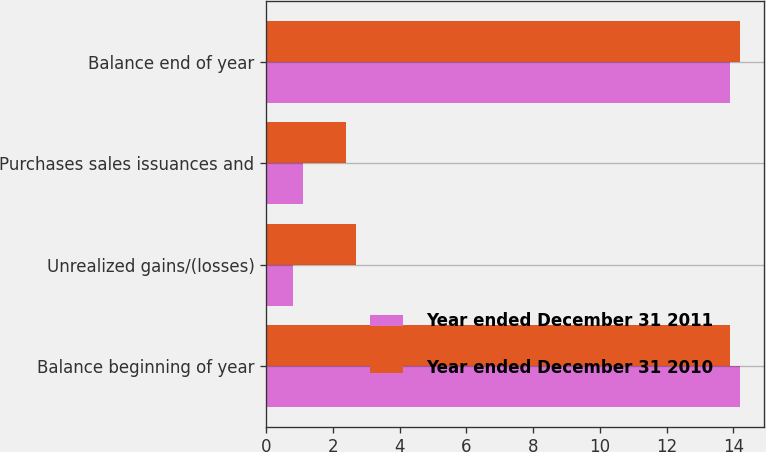Convert chart to OTSL. <chart><loc_0><loc_0><loc_500><loc_500><stacked_bar_chart><ecel><fcel>Balance beginning of year<fcel>Unrealized gains/(losses)<fcel>Purchases sales issuances and<fcel>Balance end of year<nl><fcel>Year ended December 31 2011<fcel>14.2<fcel>0.8<fcel>1.1<fcel>13.9<nl><fcel>Year ended December 31 2010<fcel>13.9<fcel>2.7<fcel>2.4<fcel>14.2<nl></chart> 